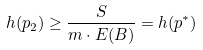<formula> <loc_0><loc_0><loc_500><loc_500>h ( p _ { 2 } ) \geq \frac { S } { m \cdot E ( B ) } = h ( p ^ { * } )</formula> 